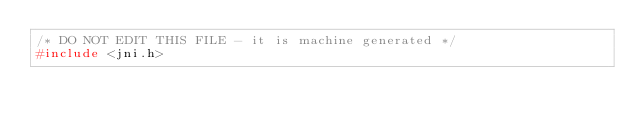<code> <loc_0><loc_0><loc_500><loc_500><_C_>/* DO NOT EDIT THIS FILE - it is machine generated */
#include <jni.h></code> 